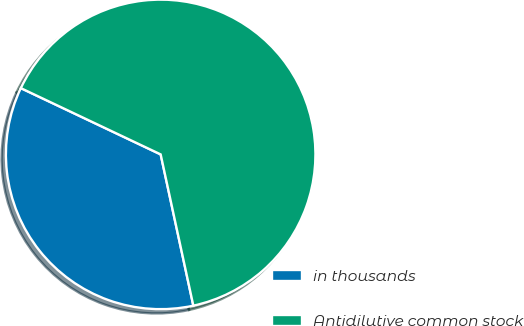<chart> <loc_0><loc_0><loc_500><loc_500><pie_chart><fcel>in thousands<fcel>Antidilutive common stock<nl><fcel>35.43%<fcel>64.57%<nl></chart> 